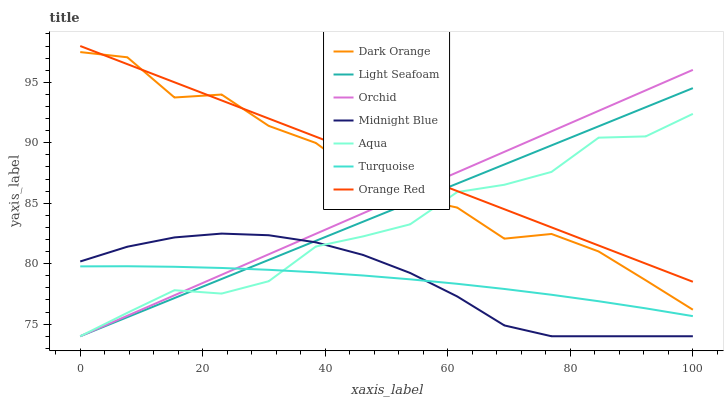Does Turquoise have the minimum area under the curve?
Answer yes or no. Yes. Does Orange Red have the maximum area under the curve?
Answer yes or no. Yes. Does Midnight Blue have the minimum area under the curve?
Answer yes or no. No. Does Midnight Blue have the maximum area under the curve?
Answer yes or no. No. Is Light Seafoam the smoothest?
Answer yes or no. Yes. Is Dark Orange the roughest?
Answer yes or no. Yes. Is Turquoise the smoothest?
Answer yes or no. No. Is Turquoise the roughest?
Answer yes or no. No. Does Midnight Blue have the lowest value?
Answer yes or no. Yes. Does Turquoise have the lowest value?
Answer yes or no. No. Does Orange Red have the highest value?
Answer yes or no. Yes. Does Midnight Blue have the highest value?
Answer yes or no. No. Is Midnight Blue less than Orange Red?
Answer yes or no. Yes. Is Dark Orange greater than Turquoise?
Answer yes or no. Yes. Does Light Seafoam intersect Aqua?
Answer yes or no. Yes. Is Light Seafoam less than Aqua?
Answer yes or no. No. Is Light Seafoam greater than Aqua?
Answer yes or no. No. Does Midnight Blue intersect Orange Red?
Answer yes or no. No. 